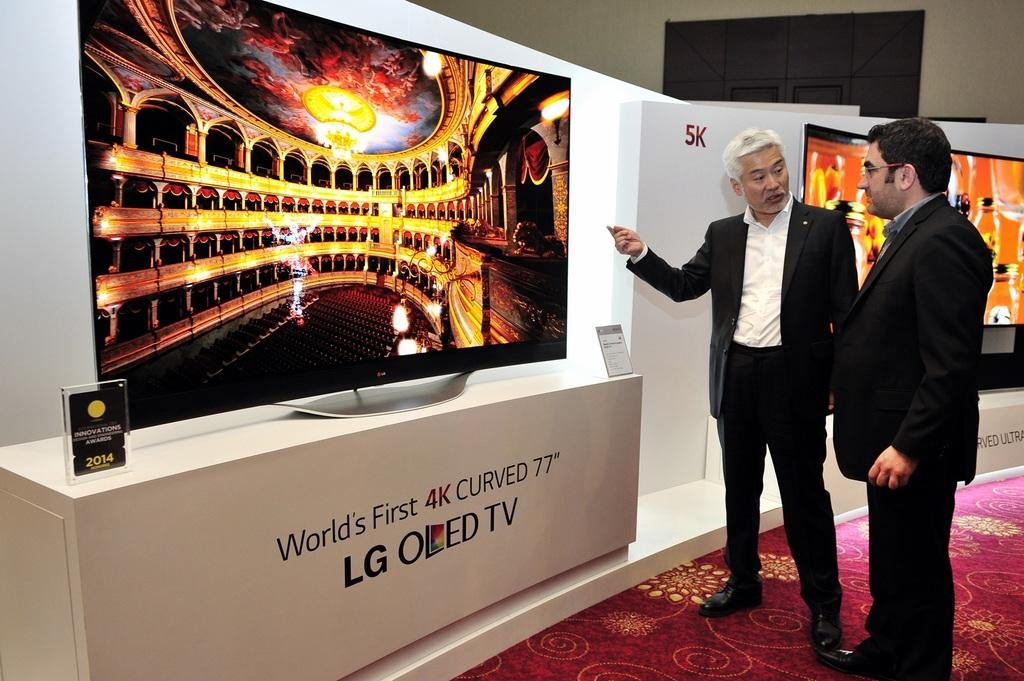<image>
Write a terse but informative summary of the picture. Two men are in front of a 4K Curved 77" LG OLED TV. 